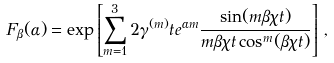Convert formula to latex. <formula><loc_0><loc_0><loc_500><loc_500>F _ { \beta } ( \alpha ) = \exp \left [ \sum _ { m = 1 } ^ { 3 } 2 \gamma ^ { ( m ) } t e ^ { \alpha m } \frac { \sin ( m \beta \chi t ) } { m \beta \chi t \cos ^ { m } ( \beta \chi t ) } \right ] \, ,</formula> 